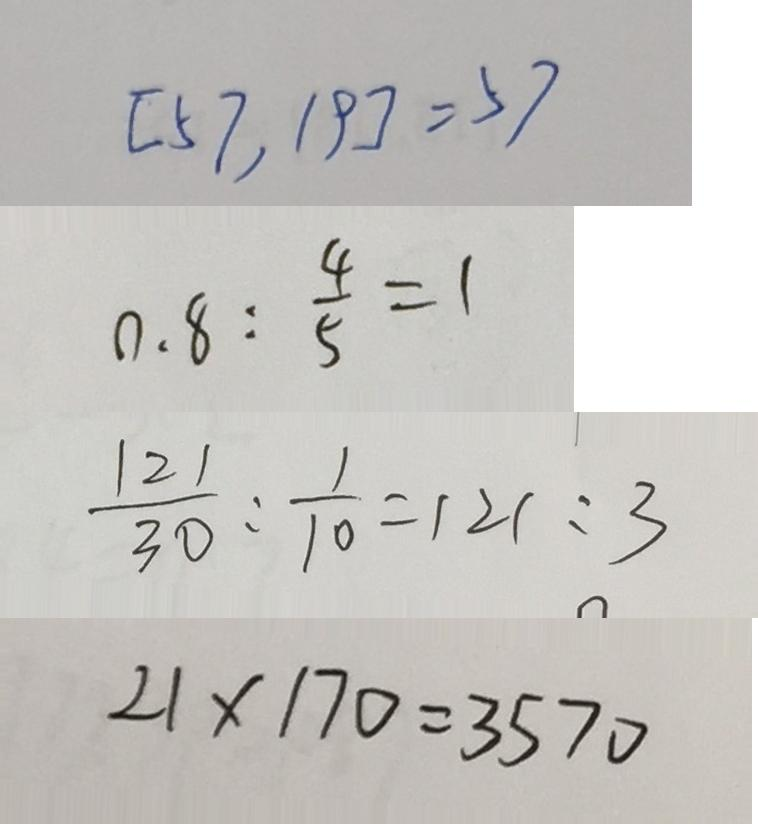<formula> <loc_0><loc_0><loc_500><loc_500>[ 5 7 , 1 9 ] = 5 7 
 0 . 8 : \frac { 4 } { 5 } = 1 
 \frac { 1 2 1 } { 3 0 } : \frac { 1 } { 1 0 } = 1 2 1 : 3 
 2 1 \times 1 7 0 = 3 5 7 0</formula> 